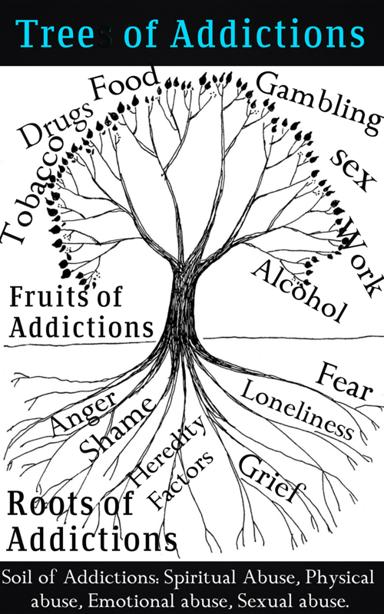What are the different parts of the Tree of Addictions mentioned in the image? The image illustrates the Tree of Addictions, which artistically segments the facets of addiction into several parts. Firstly, the branches of the tree list the various Addictions, including Drugs, Food, Gambling, Sex, Work, and Alcohol. Secondly, the Fruits of Addictions hang from the branches, representing the emotional repercussions such as Fear, Anger, Shame, Loneliness, and Grief. The Roots of Addictions delve into underlying factors, highlighting Hereditary Factors. Finally, the Soil of Addictions underscores the foundational contributors, including forms of abuse like Spiritual, Physical, Emotional, and Sexual abuse. This holistic representation aids in understanding how each element interacts and impacts the other, creating a full picture of the cycle and impact of addiction. 